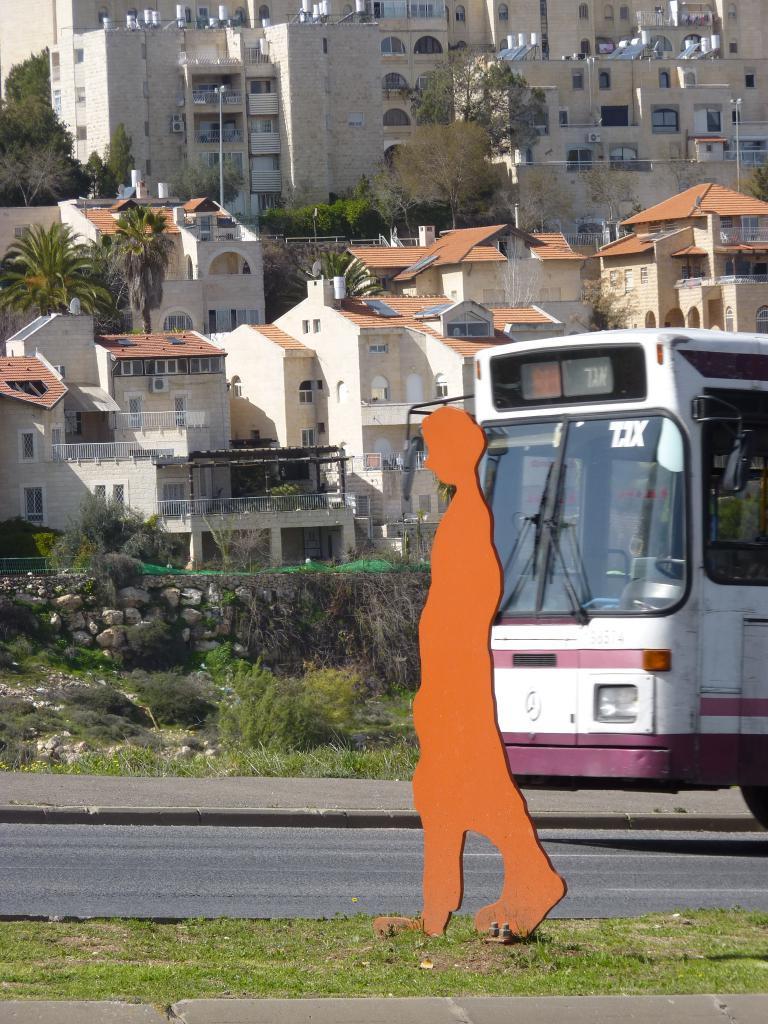Can you describe this image briefly? In this picture there are buildings and trees. In the foreground there is a bus on the road and there is a picture of a person on the footpath. At the bottom there is a road and there is grass. 